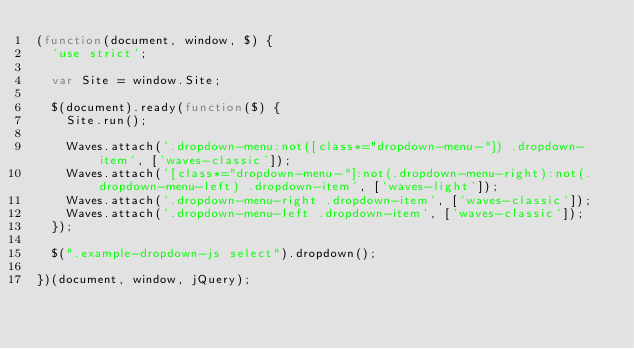<code> <loc_0><loc_0><loc_500><loc_500><_JavaScript_>(function(document, window, $) {
  'use strict';

  var Site = window.Site;

  $(document).ready(function($) {
    Site.run();

    Waves.attach('.dropdown-menu:not([class*="dropdown-menu-"]) .dropdown-item', ['waves-classic']);
    Waves.attach('[class*="dropdown-menu-"]:not(.dropdown-menu-right):not(.dropdown-menu-left) .dropdown-item', ['waves-light']);
    Waves.attach('.dropdown-menu-right .dropdown-item', ['waves-classic']);
    Waves.attach('.dropdown-menu-left .dropdown-item', ['waves-classic']);
  });

  $(".example-dropdown-js select").dropdown();

})(document, window, jQuery);
</code> 